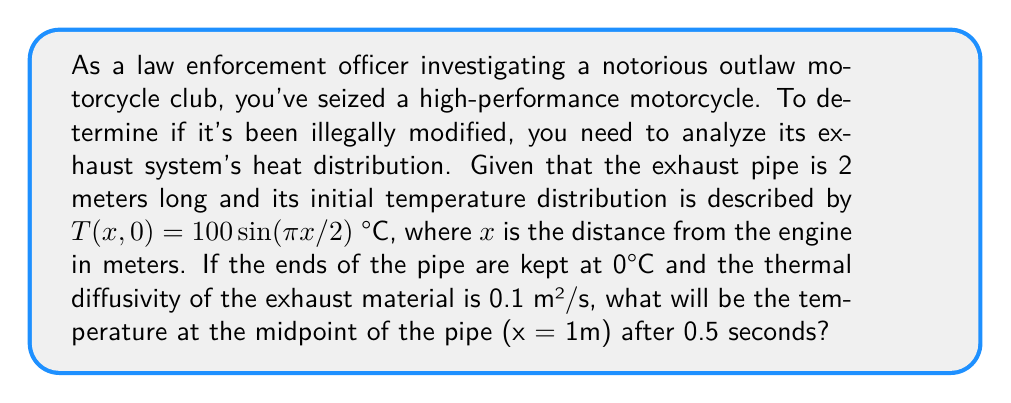Give your solution to this math problem. To solve this problem, we'll use the heat equation and its solution for a finite rod with fixed end temperatures:

1) The heat equation in one dimension is:
   $$\frac{\partial T}{\partial t} = \alpha \frac{\partial^2 T}{\partial x^2}$$
   where $\alpha$ is the thermal diffusivity.

2) The general solution for a rod of length L with fixed end temperatures is:
   $$T(x,t) = \sum_{n=1}^{\infty} B_n \sin(\frac{n\pi x}{L}) e^{-\alpha(\frac{n\pi}{L})^2t}$$

3) In our case, L = 2m and the initial condition is:
   $$T(x,0) = 100\sin(\frac{\pi x}{2})$$

4) Comparing this with the general solution at t=0, we see that only the n=1 term is non-zero, with B₁ = 100.

5) Therefore, our solution is:
   $$T(x,t) = 100 \sin(\frac{\pi x}{2}) e^{-0.1(\frac{\pi}{2})^2t}$$

6) At the midpoint (x = 1m) and t = 0.5s:
   $$T(1,0.5) = 100 \sin(\frac{\pi}{2}) e^{-0.1(\frac{\pi}{2})^2(0.5)}$$

7) Simplify:
   $$T(1,0.5) = 100 \cdot 1 \cdot e^{-0.1(\frac{\pi^2}{4})(0.5)} \approx 88.08°C$$
Answer: 88.08°C 